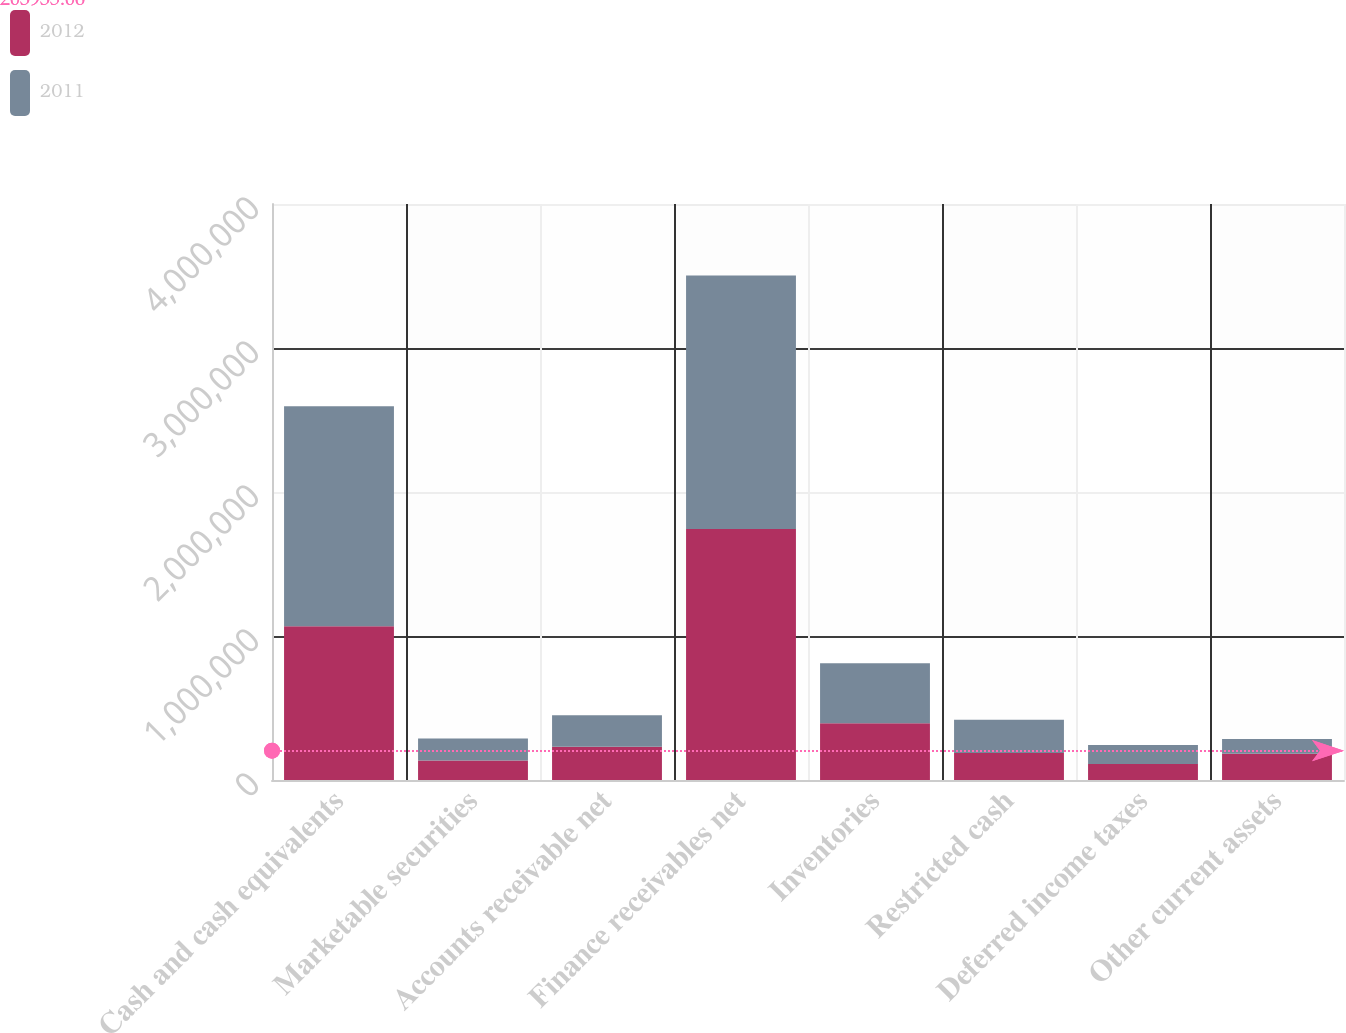Convert chart. <chart><loc_0><loc_0><loc_500><loc_500><stacked_bar_chart><ecel><fcel>Cash and cash equivalents<fcel>Marketable securities<fcel>Accounts receivable net<fcel>Finance receivables net<fcel>Inventories<fcel>Restricted cash<fcel>Deferred income taxes<fcel>Other current assets<nl><fcel>2012<fcel>1.06814e+06<fcel>135634<fcel>230079<fcel>1.74304e+06<fcel>393524<fcel>188008<fcel>110853<fcel>181655<nl><fcel>2011<fcel>1.52695e+06<fcel>153380<fcel>219039<fcel>1.76047e+06<fcel>418006<fcel>229655<fcel>132331<fcel>102378<nl></chart> 